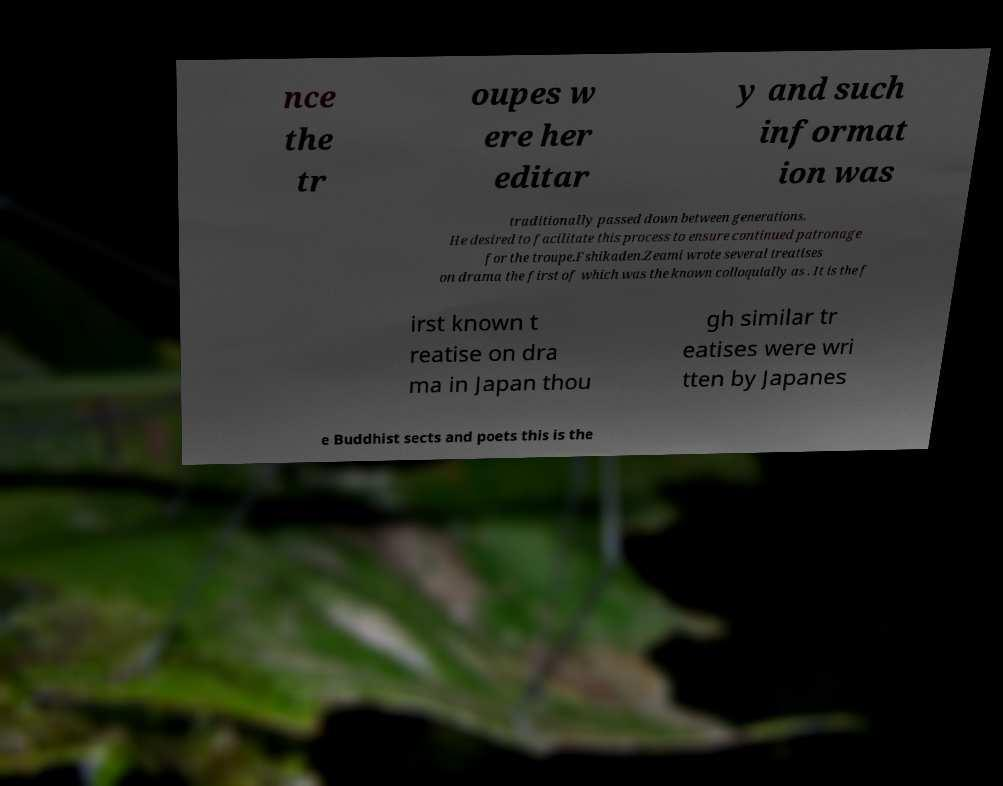Please read and relay the text visible in this image. What does it say? nce the tr oupes w ere her editar y and such informat ion was traditionally passed down between generations. He desired to facilitate this process to ensure continued patronage for the troupe.Fshikaden.Zeami wrote several treatises on drama the first of which was the known colloquially as . It is the f irst known t reatise on dra ma in Japan thou gh similar tr eatises were wri tten by Japanes e Buddhist sects and poets this is the 